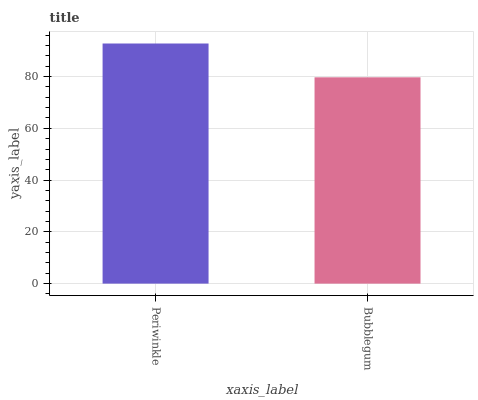Is Bubblegum the minimum?
Answer yes or no. Yes. Is Periwinkle the maximum?
Answer yes or no. Yes. Is Bubblegum the maximum?
Answer yes or no. No. Is Periwinkle greater than Bubblegum?
Answer yes or no. Yes. Is Bubblegum less than Periwinkle?
Answer yes or no. Yes. Is Bubblegum greater than Periwinkle?
Answer yes or no. No. Is Periwinkle less than Bubblegum?
Answer yes or no. No. Is Periwinkle the high median?
Answer yes or no. Yes. Is Bubblegum the low median?
Answer yes or no. Yes. Is Bubblegum the high median?
Answer yes or no. No. Is Periwinkle the low median?
Answer yes or no. No. 